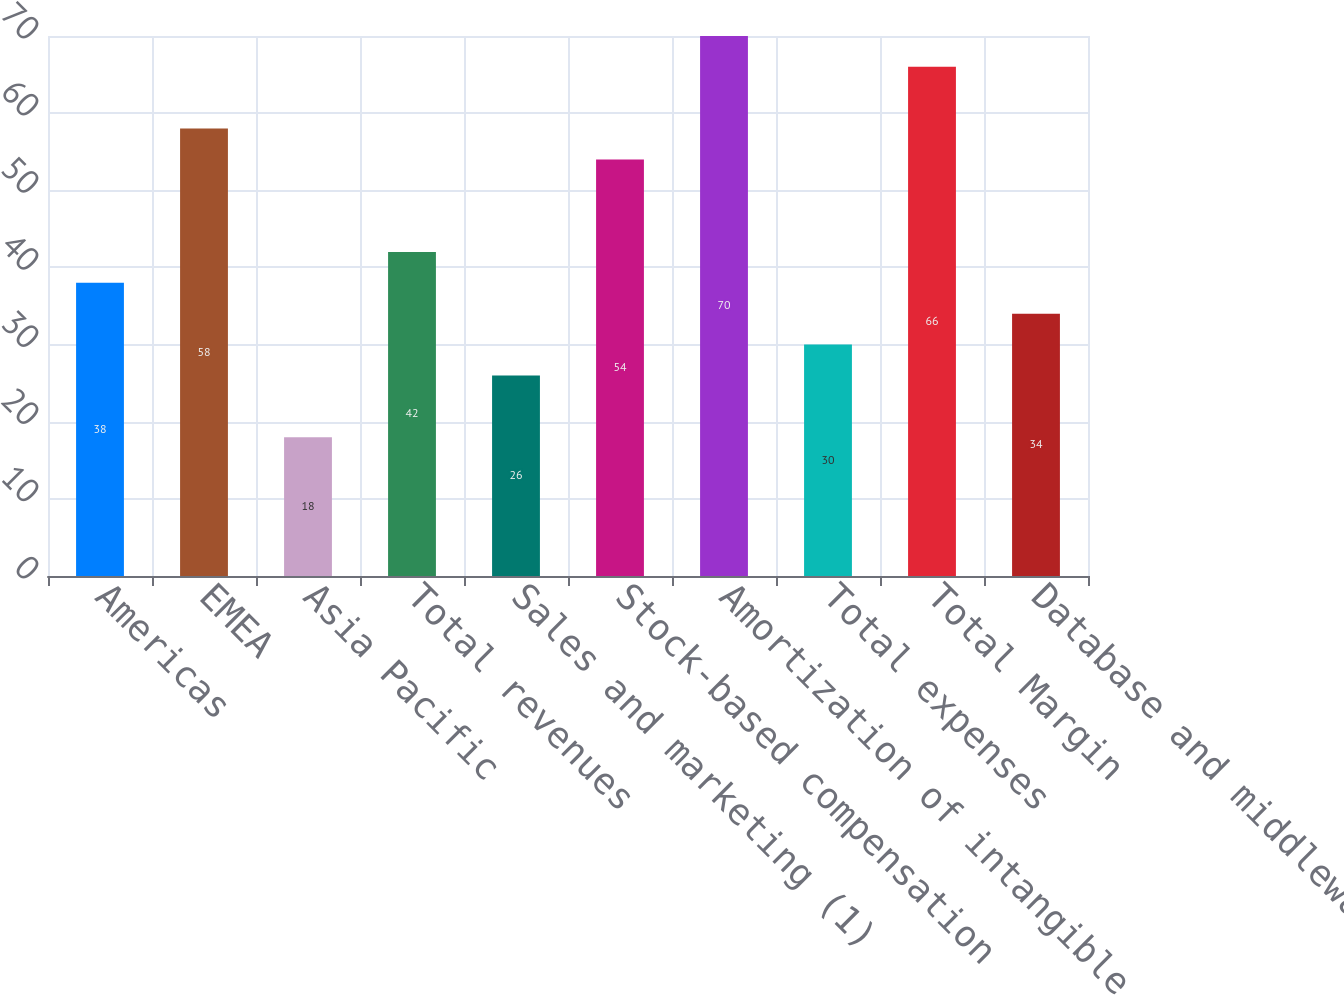<chart> <loc_0><loc_0><loc_500><loc_500><bar_chart><fcel>Americas<fcel>EMEA<fcel>Asia Pacific<fcel>Total revenues<fcel>Sales and marketing (1)<fcel>Stock-based compensation<fcel>Amortization of intangible<fcel>Total expenses<fcel>Total Margin<fcel>Database and middleware<nl><fcel>38<fcel>58<fcel>18<fcel>42<fcel>26<fcel>54<fcel>70<fcel>30<fcel>66<fcel>34<nl></chart> 